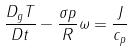Convert formula to latex. <formula><loc_0><loc_0><loc_500><loc_500>\frac { D _ { g } T } { D t } - \frac { \sigma p } { R } \omega = \frac { J } { c _ { p } }</formula> 